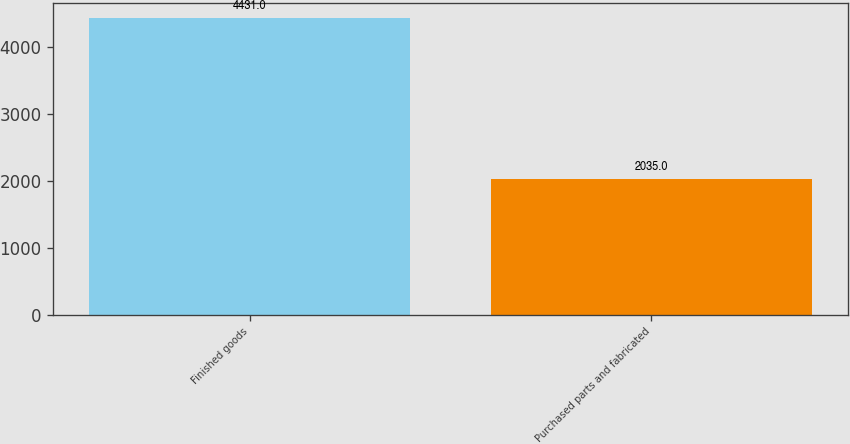Convert chart. <chart><loc_0><loc_0><loc_500><loc_500><bar_chart><fcel>Finished goods<fcel>Purchased parts and fabricated<nl><fcel>4431<fcel>2035<nl></chart> 